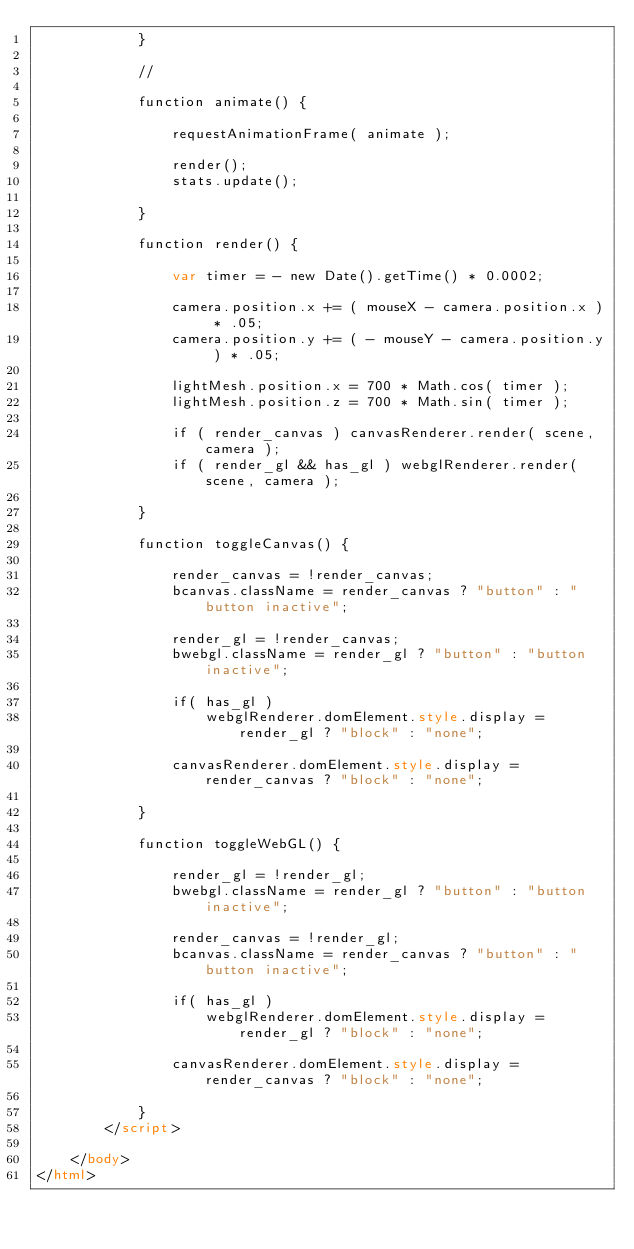Convert code to text. <code><loc_0><loc_0><loc_500><loc_500><_HTML_>			}

			//

			function animate() {

				requestAnimationFrame( animate );

				render();
				stats.update();

			}

			function render() {

				var timer = - new Date().getTime() * 0.0002;

				camera.position.x += ( mouseX - camera.position.x ) * .05;
				camera.position.y += ( - mouseY - camera.position.y ) * .05;

				lightMesh.position.x = 700 * Math.cos( timer );
				lightMesh.position.z = 700 * Math.sin( timer );

				if ( render_canvas ) canvasRenderer.render( scene, camera );
				if ( render_gl && has_gl ) webglRenderer.render( scene, camera );

			}

			function toggleCanvas() {

				render_canvas = !render_canvas;
				bcanvas.className = render_canvas ? "button" : "button inactive";

				render_gl = !render_canvas;
				bwebgl.className = render_gl ? "button" : "button inactive";

				if( has_gl )
					webglRenderer.domElement.style.display = render_gl ? "block" : "none";

				canvasRenderer.domElement.style.display = render_canvas ? "block" : "none";

			}

			function toggleWebGL() {

				render_gl = !render_gl;
				bwebgl.className = render_gl ? "button" : "button inactive";

				render_canvas = !render_gl;
				bcanvas.className = render_canvas ? "button" : "button inactive";

				if( has_gl )
					webglRenderer.domElement.style.display = render_gl ? "block" : "none";

				canvasRenderer.domElement.style.display = render_canvas ? "block" : "none";

			}
		</script>

	</body>
</html>
</code> 